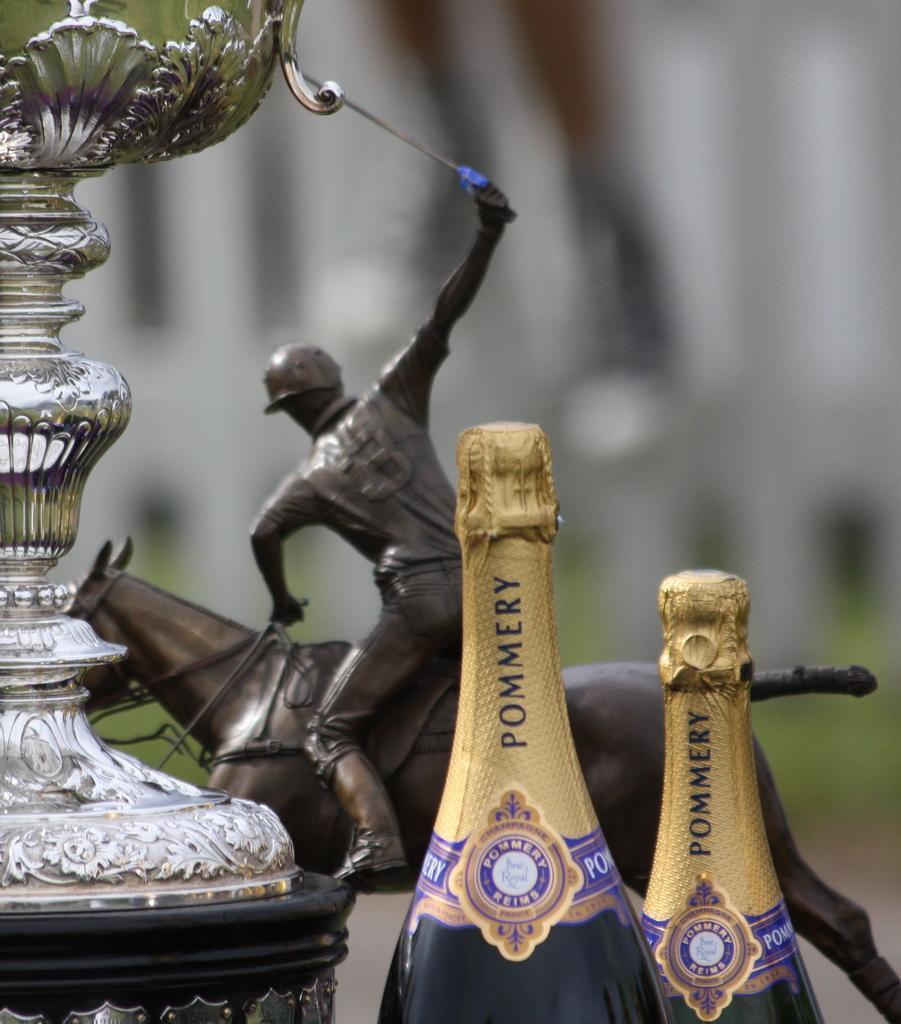Can you describe this image briefly? Here we can see a statue of a person on the horse, bottles, and an object. There is a blur background. 